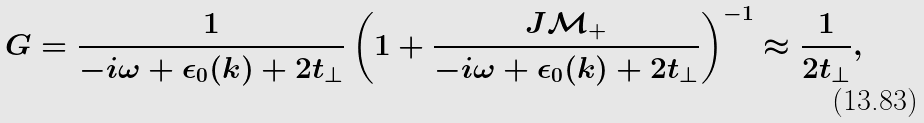Convert formula to latex. <formula><loc_0><loc_0><loc_500><loc_500>G = \frac { 1 } { - i \omega + \epsilon _ { 0 } ( k ) + 2 t _ { \perp } } \left ( 1 + \frac { J \mathcal { M } _ { + } } { - i \omega + \epsilon _ { 0 } ( k ) + 2 t _ { \perp } } \right ) ^ { - 1 } \approx \frac { 1 } { 2 t _ { \perp } } ,</formula> 